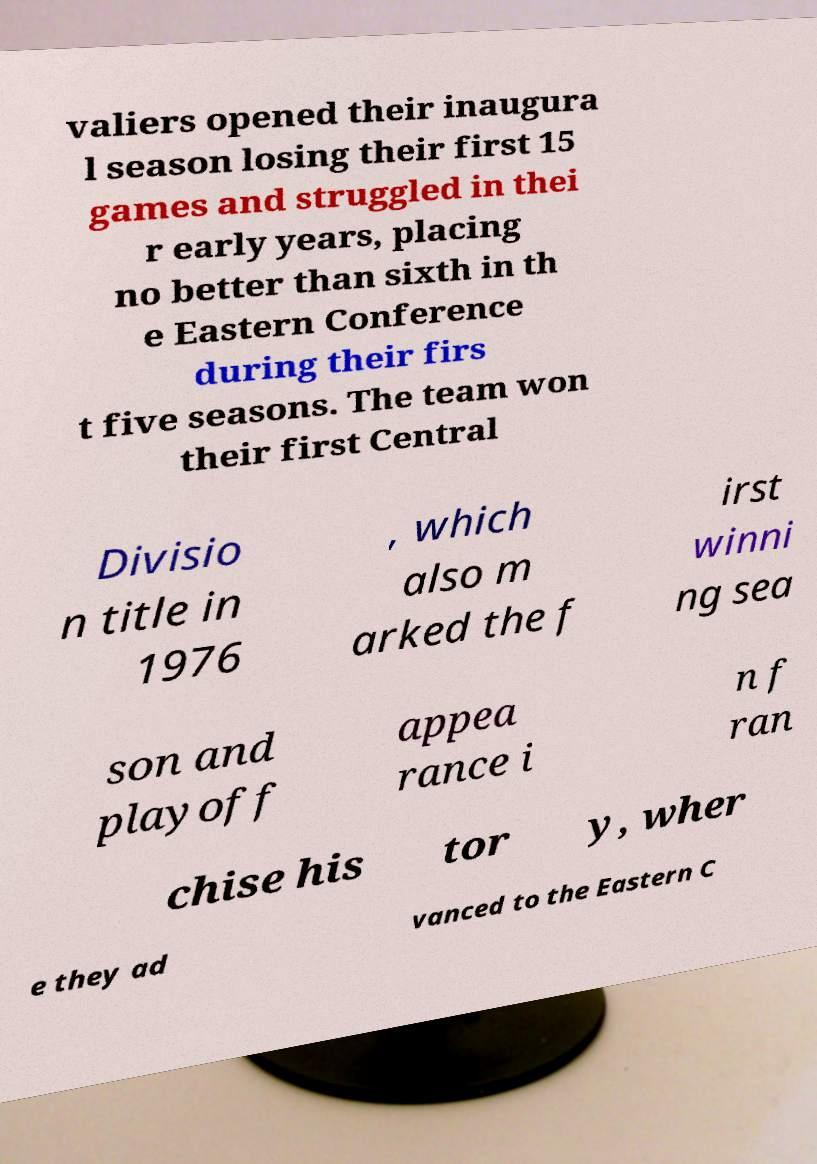Please read and relay the text visible in this image. What does it say? valiers opened their inaugura l season losing their first 15 games and struggled in thei r early years, placing no better than sixth in th e Eastern Conference during their firs t five seasons. The team won their first Central Divisio n title in 1976 , which also m arked the f irst winni ng sea son and playoff appea rance i n f ran chise his tor y, wher e they ad vanced to the Eastern C 